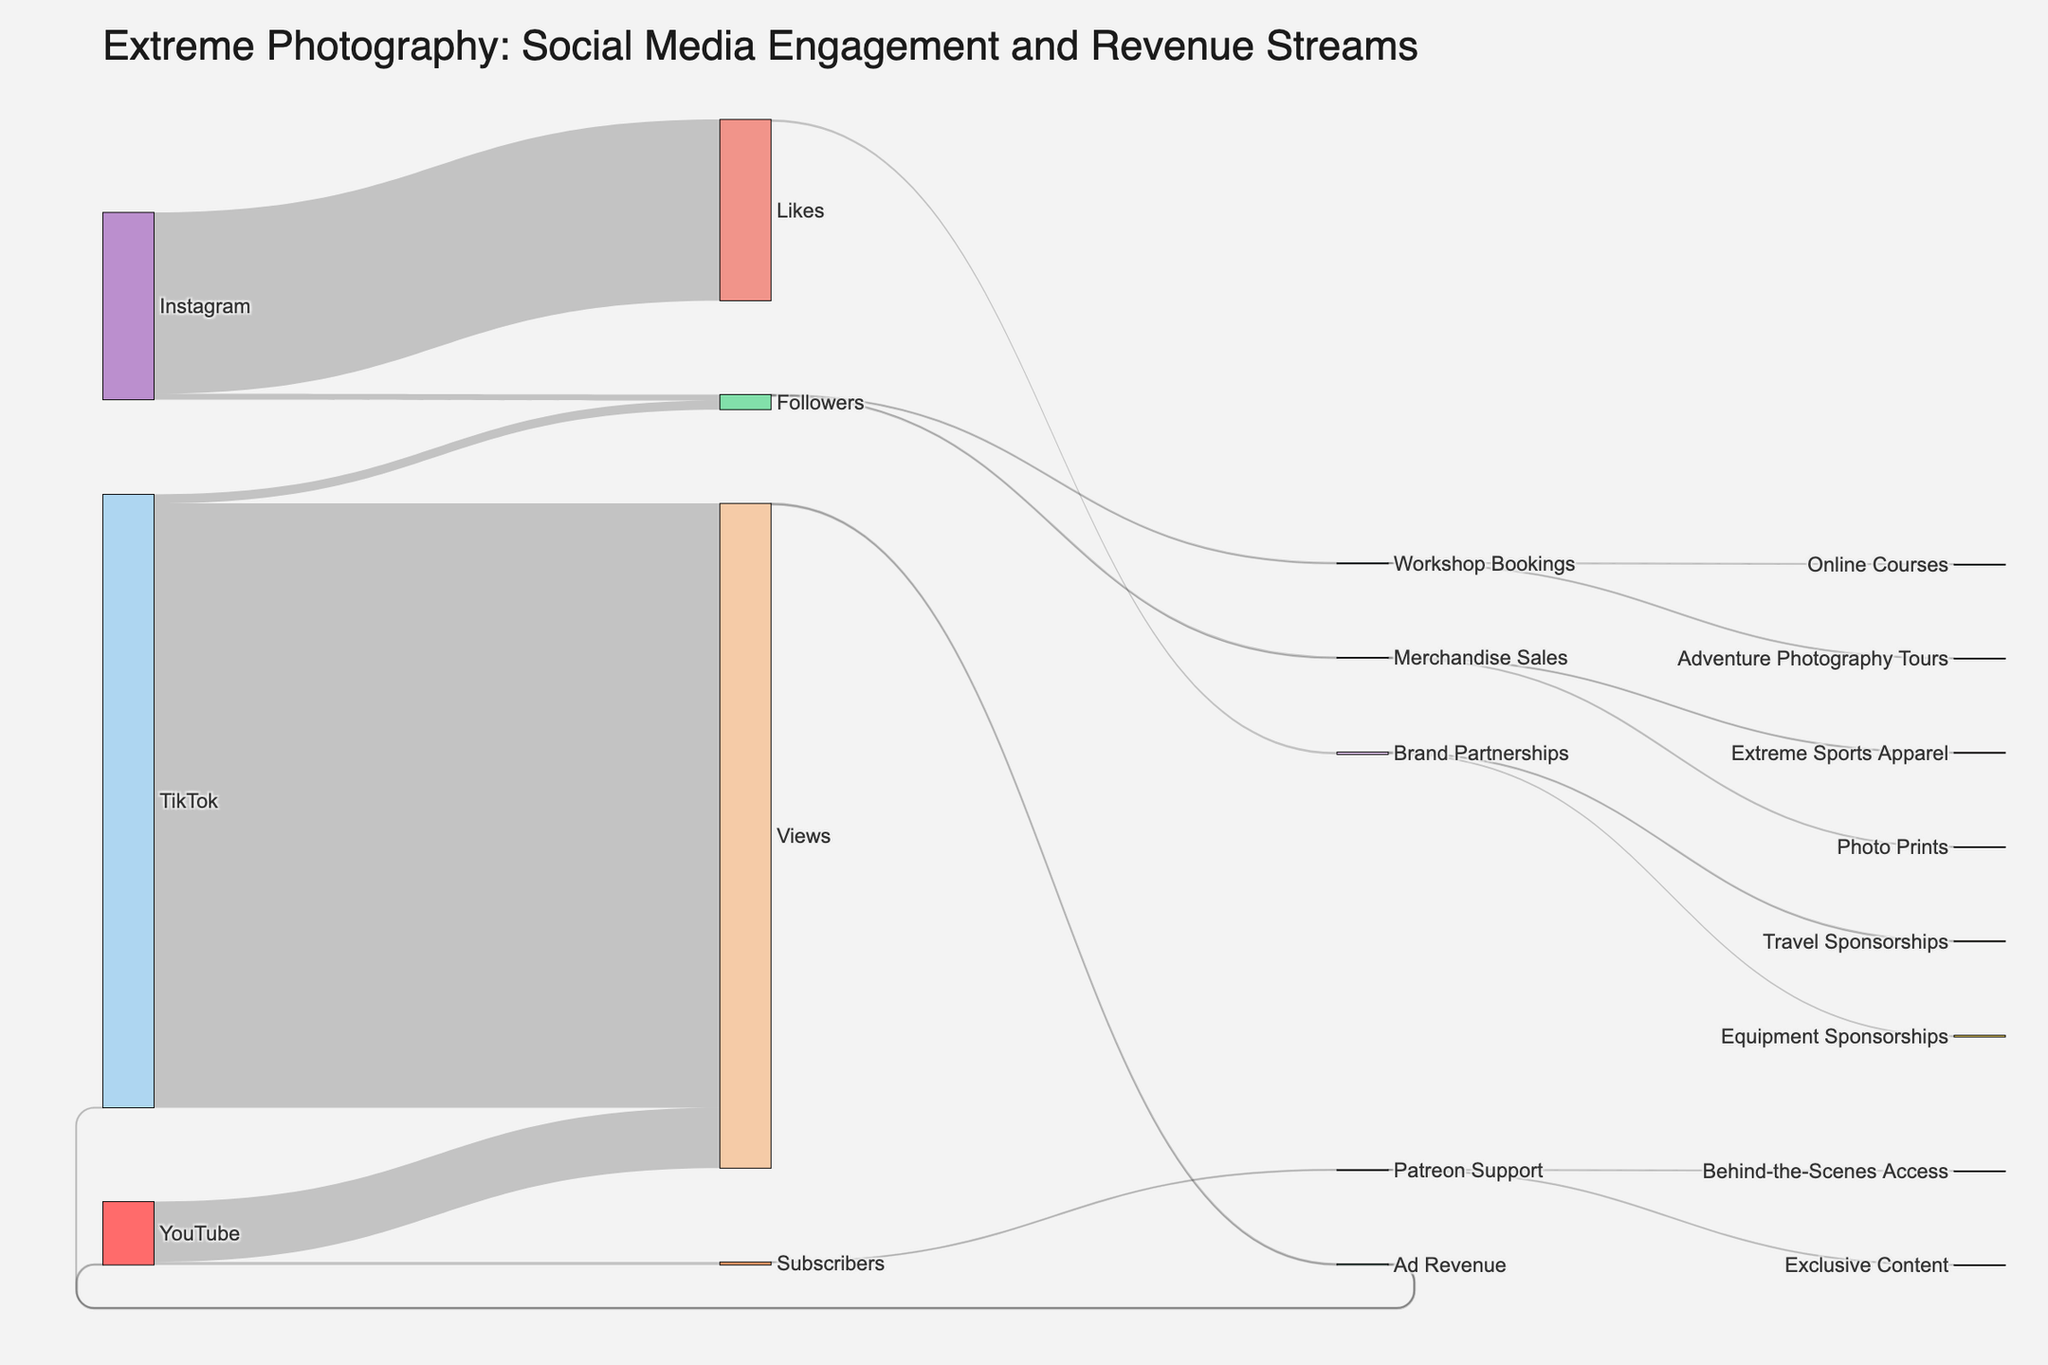what is the total number of followers on Instagram? Look at the "Followers" node connected to "Instagram" and check the value.
Answer: 500000 How many more viewers does TikTok have compared to YouTube? Locate the "Views" nodes for both TikTok and YouTube, and then find the difference between their values. TikTok has 50,000,000 views and YouTube has 5,000,000 views; the difference is 50,000,000 - 5,000,000.
Answer: 45000000 What is the main revenue stream with the highest value connected to Followers? Identify the revenue streams connected to the "Followers" node and compare the values. Merchandise Sales has 75,000, and Workshop Bookings has 50,000.
Answer: Merchandise Sales Name two types of merchandise linked to Merchandise Sales and their values. Follow the links from the "Merchandise Sales" node and list out the target nodes and their corresponding values.
Answer: Extreme Sports Apparel: 45000, Photo Prints: 30000 Which type of support generates more value from Subscribers: Patreon Support or Ad Revenue? Compare the values linked to the "Subscribers" node through both revenue streams. Patreon Support is 30,000, while Ad Revenue linked to YouTube is 80,000.
Answer: Ad Revenue How many brand partnerships exist and what are their total values combined? Count the number of target nodes connected to "Brand Partnerships" and sum their values. Equipment Sponsorships is 150,000 and Travel Sponsorships is 50,000; the total is 150,000 + 50,000.
Answer: 2 partnerships, total value: 200000 Where does the highest value of Ad Revenue come from and what is its value? Check the "Ad Revenue" connections and their respective values. The value from YouTube is 80,000.
Answer: YouTube, 80000 What's the sum of all values leading to the Brand Partnerships node? Identify all source nodes going into "Brand Partnerships" and sum their values.
Answer: 200000 